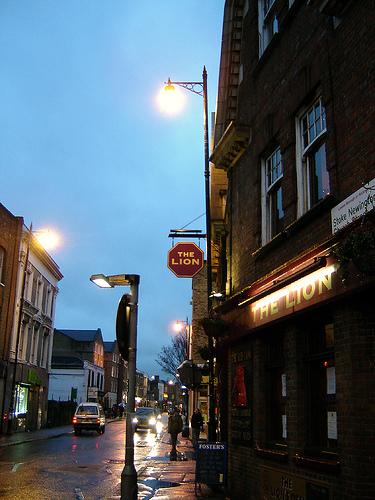Is this a big city?
Give a very brief answer. No. How many people walking the sidewalk?
Keep it brief. 2. Does this appear to be a noisy environment?
Be succinct. No. Is this a distinct looking street light?
Keep it brief. Yes. What does the yellow print say?
Quick response, please. Lion. What establishment is on the right hand side of the street?
Keep it brief. Lion. What does the red sign say?
Write a very short answer. The lion. 